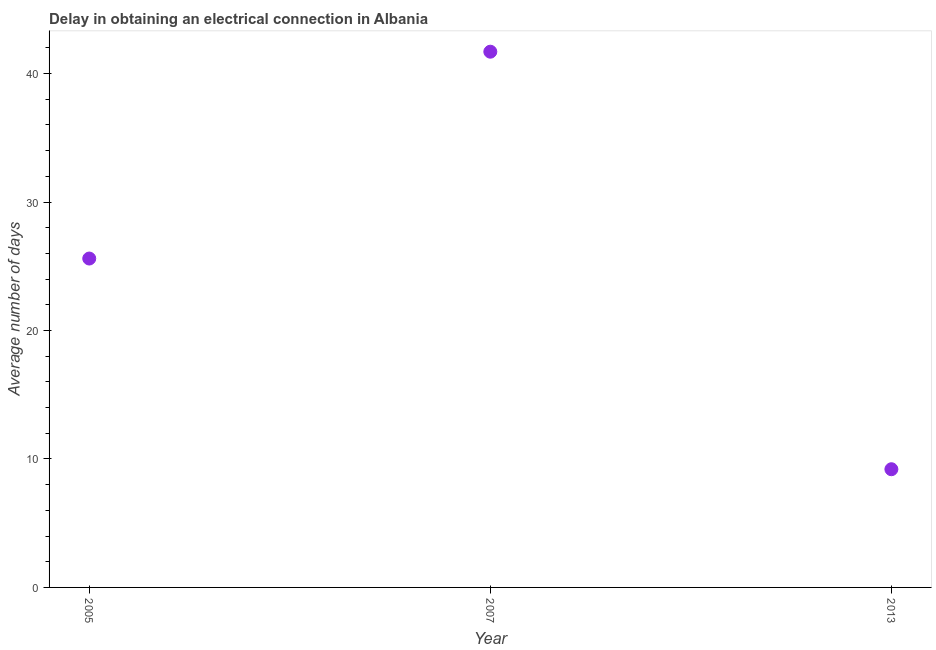What is the dalay in electrical connection in 2007?
Provide a succinct answer. 41.7. Across all years, what is the maximum dalay in electrical connection?
Provide a succinct answer. 41.7. Across all years, what is the minimum dalay in electrical connection?
Your answer should be very brief. 9.2. In which year was the dalay in electrical connection minimum?
Offer a terse response. 2013. What is the sum of the dalay in electrical connection?
Give a very brief answer. 76.5. What is the difference between the dalay in electrical connection in 2005 and 2013?
Offer a terse response. 16.4. What is the average dalay in electrical connection per year?
Make the answer very short. 25.5. What is the median dalay in electrical connection?
Your answer should be very brief. 25.6. What is the ratio of the dalay in electrical connection in 2005 to that in 2007?
Keep it short and to the point. 0.61. What is the difference between the highest and the lowest dalay in electrical connection?
Offer a very short reply. 32.5. What is the difference between two consecutive major ticks on the Y-axis?
Keep it short and to the point. 10. Are the values on the major ticks of Y-axis written in scientific E-notation?
Provide a succinct answer. No. What is the title of the graph?
Offer a terse response. Delay in obtaining an electrical connection in Albania. What is the label or title of the X-axis?
Offer a very short reply. Year. What is the label or title of the Y-axis?
Offer a very short reply. Average number of days. What is the Average number of days in 2005?
Your answer should be very brief. 25.6. What is the Average number of days in 2007?
Your answer should be very brief. 41.7. What is the Average number of days in 2013?
Ensure brevity in your answer.  9.2. What is the difference between the Average number of days in 2005 and 2007?
Keep it short and to the point. -16.1. What is the difference between the Average number of days in 2007 and 2013?
Your answer should be compact. 32.5. What is the ratio of the Average number of days in 2005 to that in 2007?
Ensure brevity in your answer.  0.61. What is the ratio of the Average number of days in 2005 to that in 2013?
Offer a terse response. 2.78. What is the ratio of the Average number of days in 2007 to that in 2013?
Your answer should be very brief. 4.53. 